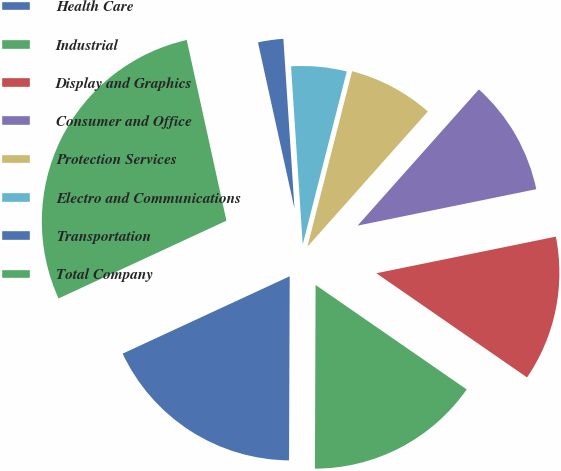Convert chart. <chart><loc_0><loc_0><loc_500><loc_500><pie_chart><fcel>Health Care<fcel>Industrial<fcel>Display and Graphics<fcel>Consumer and Office<fcel>Protection Services<fcel>Electro and Communications<fcel>Transportation<fcel>Total Company<nl><fcel>18.04%<fcel>15.43%<fcel>12.83%<fcel>10.22%<fcel>7.61%<fcel>5.01%<fcel>2.4%<fcel>28.46%<nl></chart> 